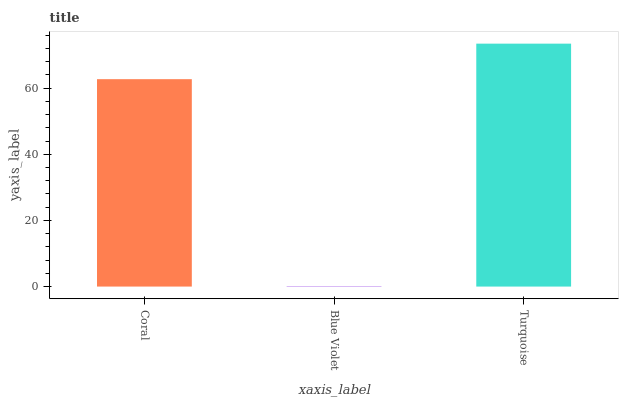Is Blue Violet the minimum?
Answer yes or no. Yes. Is Turquoise the maximum?
Answer yes or no. Yes. Is Turquoise the minimum?
Answer yes or no. No. Is Blue Violet the maximum?
Answer yes or no. No. Is Turquoise greater than Blue Violet?
Answer yes or no. Yes. Is Blue Violet less than Turquoise?
Answer yes or no. Yes. Is Blue Violet greater than Turquoise?
Answer yes or no. No. Is Turquoise less than Blue Violet?
Answer yes or no. No. Is Coral the high median?
Answer yes or no. Yes. Is Coral the low median?
Answer yes or no. Yes. Is Blue Violet the high median?
Answer yes or no. No. Is Turquoise the low median?
Answer yes or no. No. 